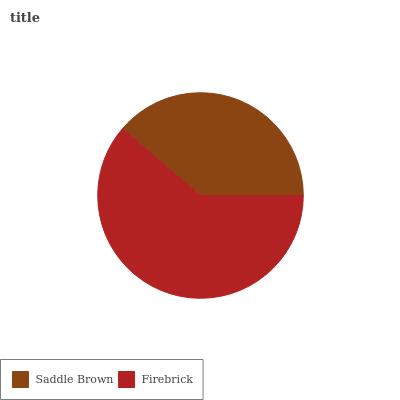Is Saddle Brown the minimum?
Answer yes or no. Yes. Is Firebrick the maximum?
Answer yes or no. Yes. Is Firebrick the minimum?
Answer yes or no. No. Is Firebrick greater than Saddle Brown?
Answer yes or no. Yes. Is Saddle Brown less than Firebrick?
Answer yes or no. Yes. Is Saddle Brown greater than Firebrick?
Answer yes or no. No. Is Firebrick less than Saddle Brown?
Answer yes or no. No. Is Firebrick the high median?
Answer yes or no. Yes. Is Saddle Brown the low median?
Answer yes or no. Yes. Is Saddle Brown the high median?
Answer yes or no. No. Is Firebrick the low median?
Answer yes or no. No. 